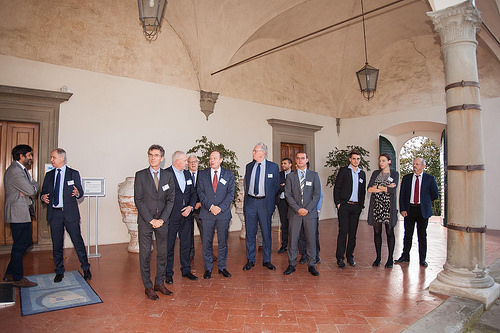<image>
Is there a light in front of the label? No. The light is not in front of the label. The spatial positioning shows a different relationship between these objects. 